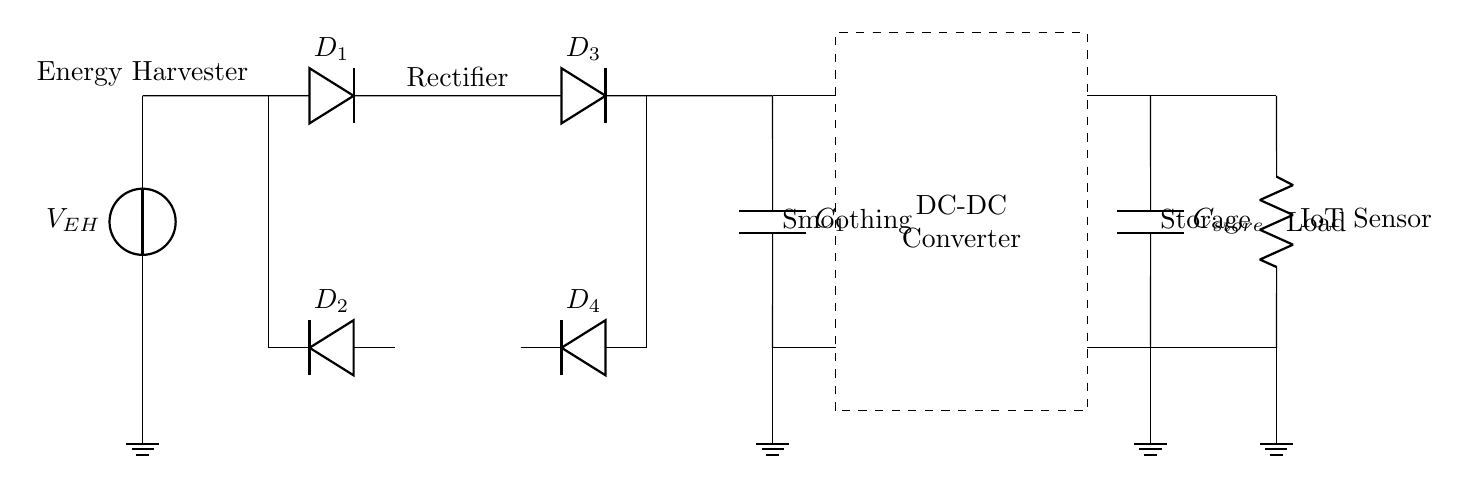What type of energy source is depicted in this circuit? The circuit shows an energy harvester as the primary energy source. This is indicated by the labeled voltage source at the left end of the diagram.
Answer: Energy harvester What is the purpose of the diodes in the circuit? The diodes are used to rectify the AC voltage generated by the energy harvester to DC voltage. This is achieved through their orientation, allowing current to flow in one direction while blocking it in the opposite direction.
Answer: Rectification How many diodes are present in the circuit? By counting the diode symbols in the diagram, there are four diodes labeled as D1, D2, D3, and D4.
Answer: Four What does the smoothing capacitor do? The smoothing capacitor, labeled as C1, helps to reduce voltage fluctuations and ripple in the output from the rectifier, ensuring a more stable DC voltage supply to the subsequent stage.
Answer: Voltage stabilization What is the function of the DC-DC converter in this circuit? The DC-DC converter adjusts the voltage level to the required range for the IoT sensor, ensuring efficient operation. Its dashed rectangle indicates this function in the overall energy management of the circuit.
Answer: Voltage adjustment What component stores energy in the circuit before supplying it to the load? The storage capacitor labeled as C_store is designed to store energy for later use, allowing the circuit to deliver power on demand when needed by the IoT sensor.
Answer: Storage capacitor What is the load in this energy harvesting circuit? The load of the circuit is an IoT sensor, indicated on the right side of the circuit diagram, which utilizes the harvested and stored energy for its operation.
Answer: IoT sensor 